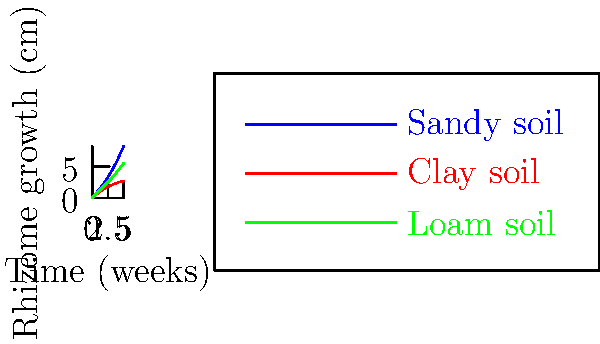Based on the graph showing fern rhizome growth patterns in different soil types over a 5-week period, calculate the average weekly growth rate for ferns in sandy soil. Express your answer in cm/week. To calculate the average weekly growth rate for ferns in sandy soil:

1. Determine total growth:
   Final length (week 5) = 8.2 cm
   Initial length (week 0) = 0 cm
   Total growth = 8.2 cm - 0 cm = 8.2 cm

2. Determine time period:
   5 weeks

3. Calculate average weekly growth rate:
   Average rate = Total growth / Time period
   $$ \text{Average rate} = \frac{8.2 \text{ cm}}{5 \text{ weeks}} = 1.64 \text{ cm/week} $$

4. Round to two decimal places:
   1.64 cm/week
Answer: 1.64 cm/week 